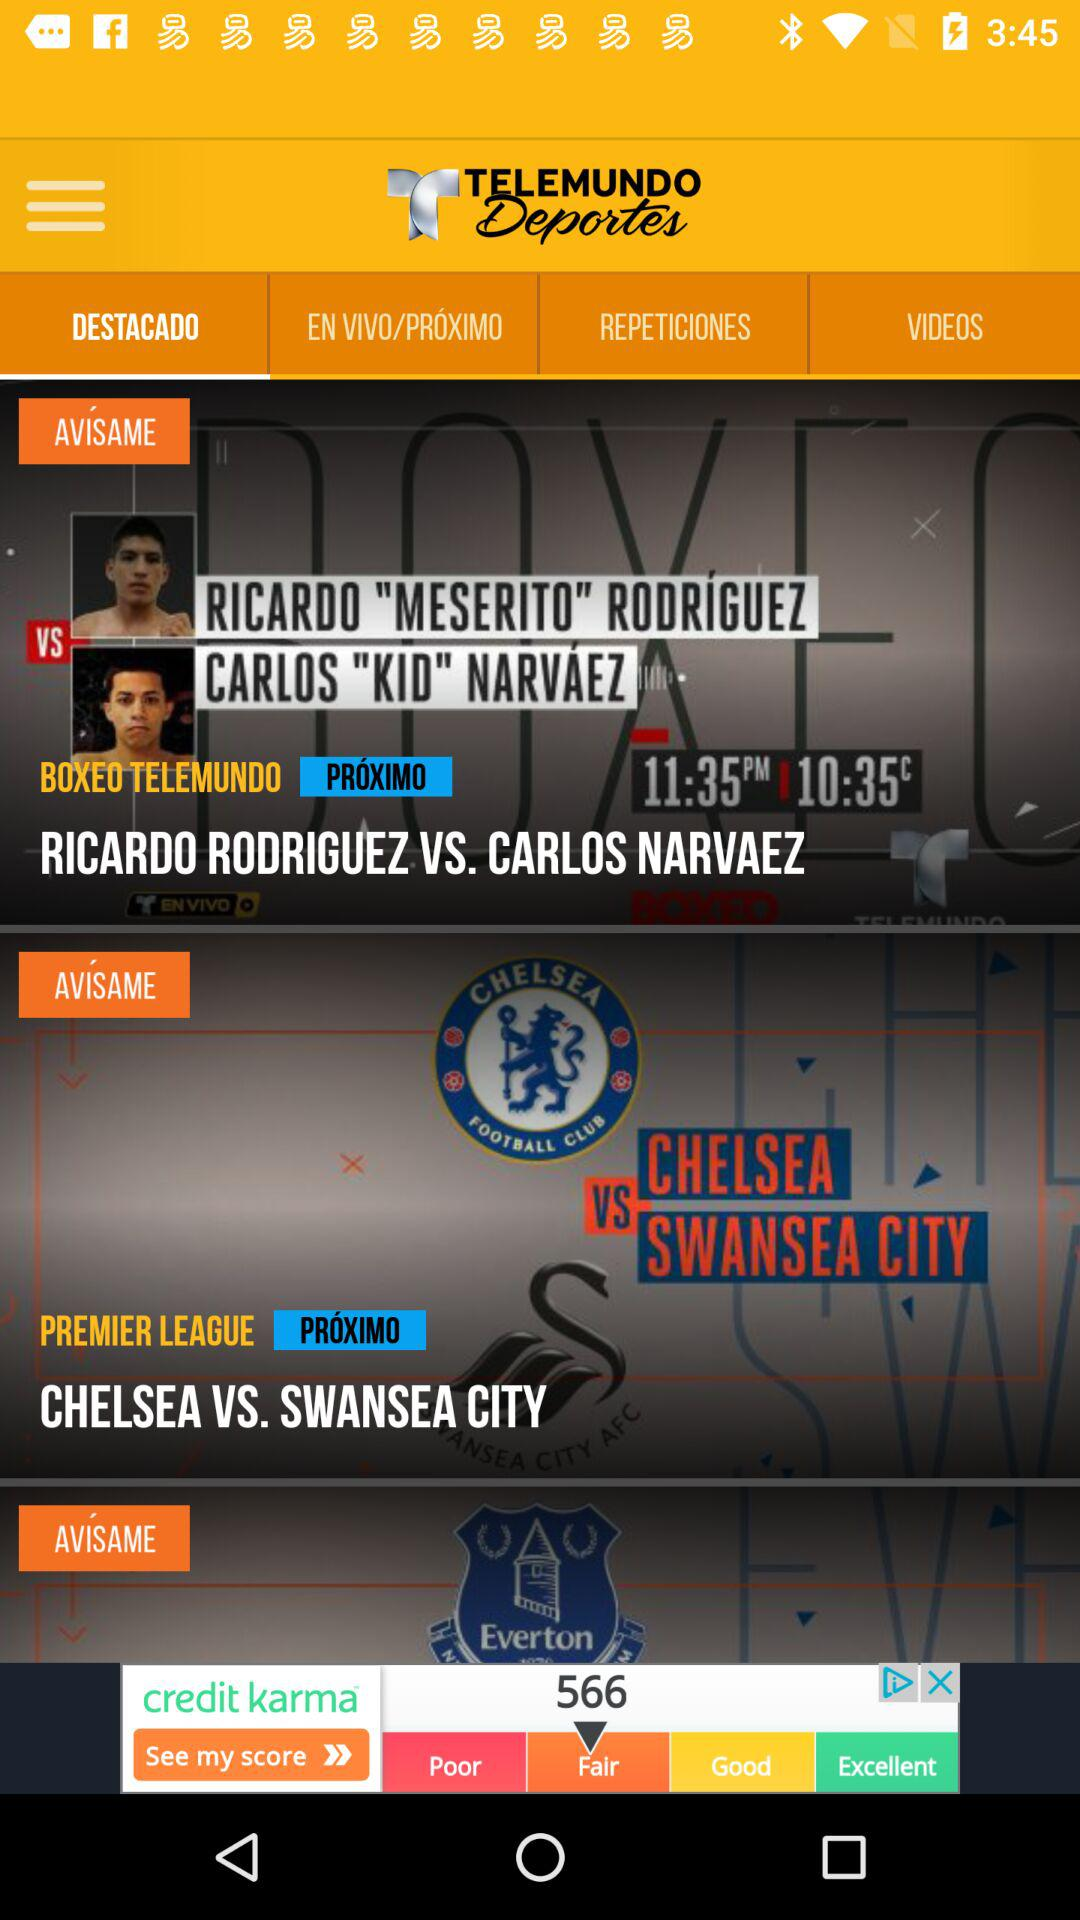How many videos are available?
When the provided information is insufficient, respond with <no answer>. <no answer> 